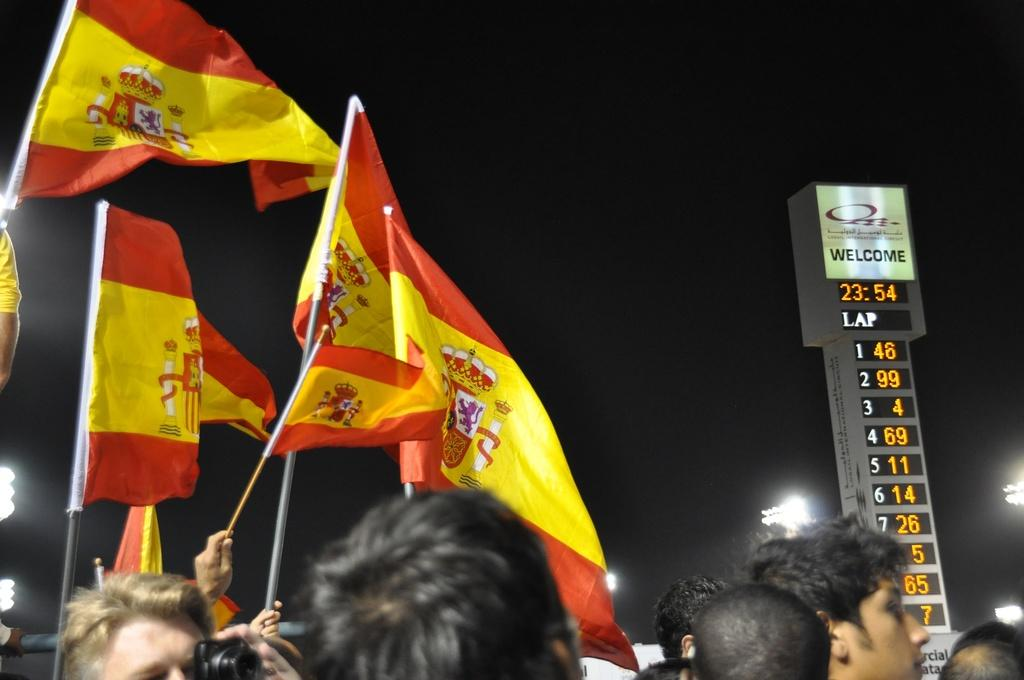What are the people in the image doing? The people in the image are holding flags. What can be seen in the background of the image? There is a scoreboard, lights, poles, and the sky visible in the background of the image. What type of government is being discussed in the image? There is no discussion of government in the image; it features a group of people holding flags and a background with a scoreboard, lights, poles, and the sky. 